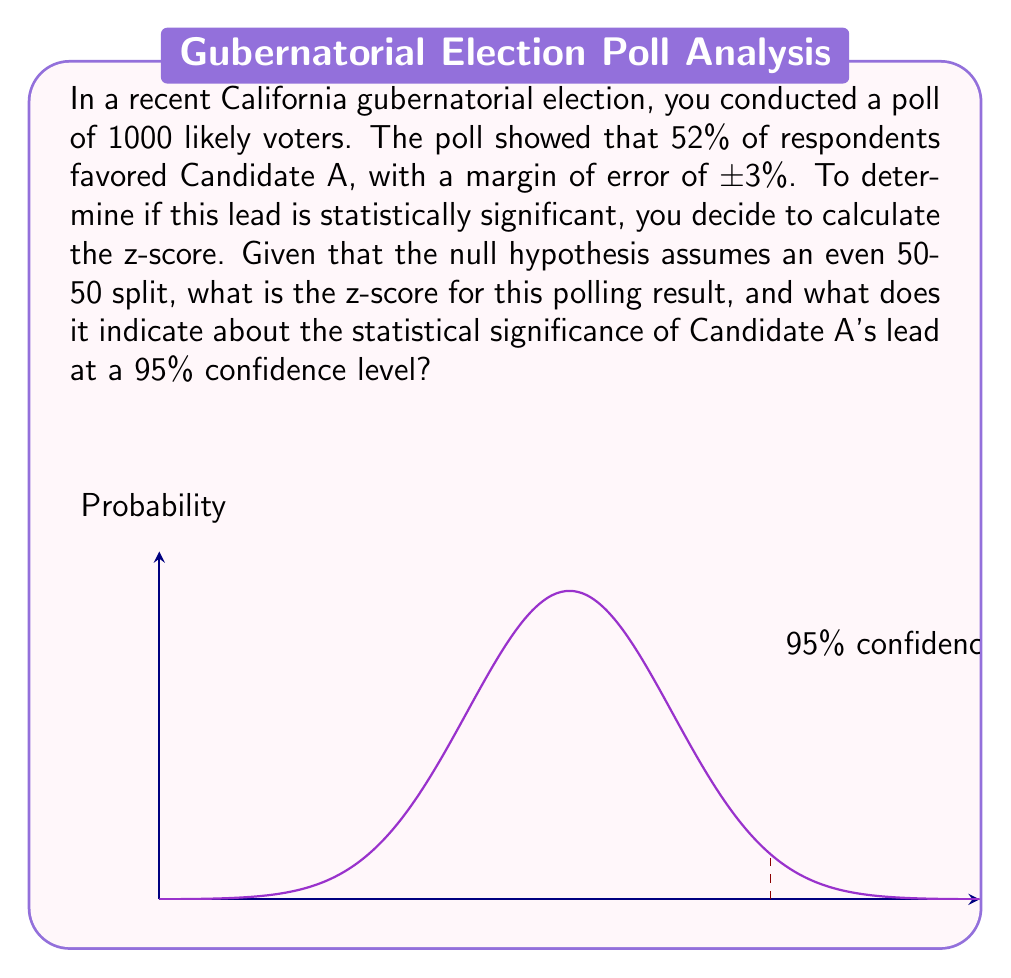Help me with this question. To calculate the z-score and determine statistical significance, we'll follow these steps:

1) The formula for z-score is:

   $$z = \frac{p - p_0}{\sqrt{\frac{p_0(1-p_0)}{n}}}$$

   Where:
   $p$ = observed proportion (0.52)
   $p_0$ = expected proportion under null hypothesis (0.50)
   $n$ = sample size (1000)

2) Plugging in the values:

   $$z = \frac{0.52 - 0.50}{\sqrt{\frac{0.50(1-0.50)}{1000}}}$$

3) Simplify:

   $$z = \frac{0.02}{\sqrt{\frac{0.25}{1000}}} = \frac{0.02}{\sqrt{0.00025}} = \frac{0.02}{0.015811}$$

4) Calculate:

   $$z \approx 1.2649$$

5) Interpretation:
   For a 95% confidence level, the critical z-score is ±1.96. Since our calculated z-score (1.2649) is less than 1.96, we cannot reject the null hypothesis at the 95% confidence level.

This means that while the poll shows a lead for Candidate A, this lead is not statistically significant at the 95% confidence level. The observed difference could be due to sampling variability rather than a true difference in the population.
Answer: $z \approx 1.2649$; Not statistically significant at 95% confidence level. 